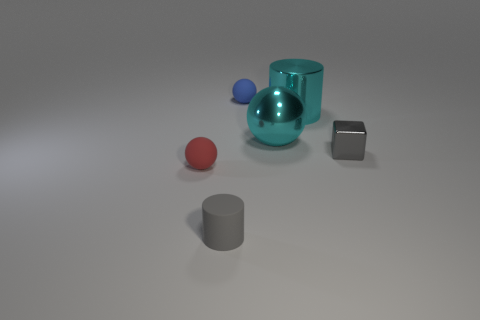Subtract all green cylinders. Subtract all brown balls. How many cylinders are left? 2 Add 1 tiny matte objects. How many objects exist? 7 Subtract all cylinders. How many objects are left? 4 Subtract 0 yellow blocks. How many objects are left? 6 Subtract all cyan metal things. Subtract all small gray metal things. How many objects are left? 3 Add 2 gray metal things. How many gray metal things are left? 3 Add 6 blocks. How many blocks exist? 7 